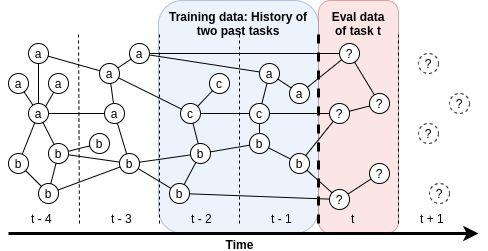How does the incorporation of 'c' compare with components 'a' and 'b' in terms of influence over time? Component 'c' appears at a later stage compared to 'a' and 'b', which are present from time t-4. This timing indicates that 'c' might have been introduced to address specific aspects or shortcomings that 'a' and 'b' did not cover. Over time, 'c' maintains a steady presence in the evaluation process, similar to 'a' and 'b', which suggests its significant and sustained influence, potentially complementing or enhancing the roles of the other components. 